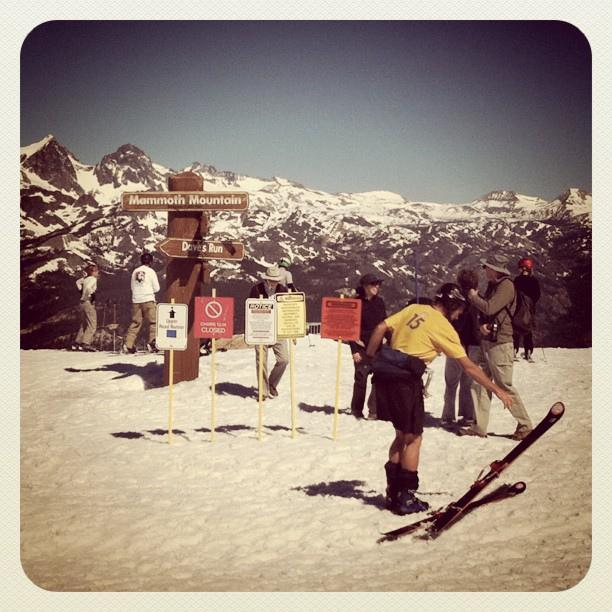Why is the man in the yellow shirt on the mountain?

Choices:
A) to hike
B) to eat
C) to ski
D) to sleep to ski 